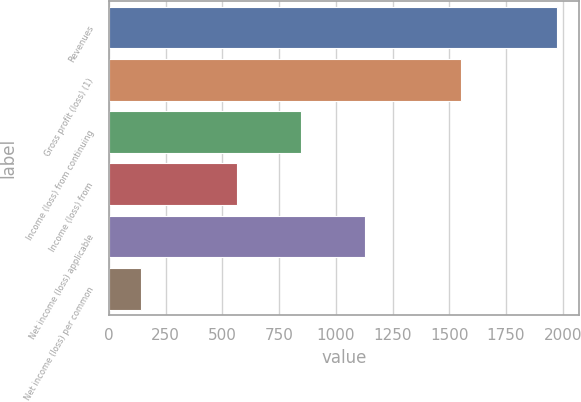Convert chart to OTSL. <chart><loc_0><loc_0><loc_500><loc_500><bar_chart><fcel>Revenues<fcel>Gross profit (loss) (1)<fcel>Income (loss) from continuing<fcel>Income (loss) from<fcel>Net income (loss) applicable<fcel>Net income (loss) per common<nl><fcel>1973.96<fcel>1550.99<fcel>846.04<fcel>564.06<fcel>1128.02<fcel>141.09<nl></chart> 